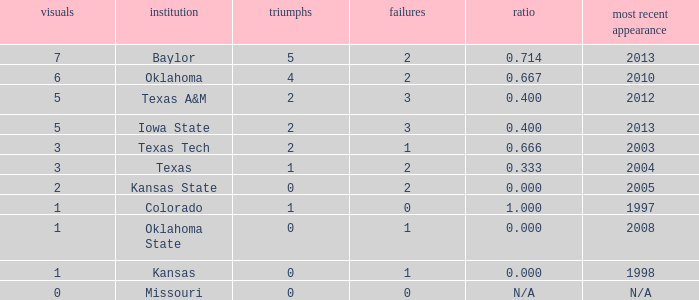How many schools had the win loss ratio of 0.667?  1.0. 